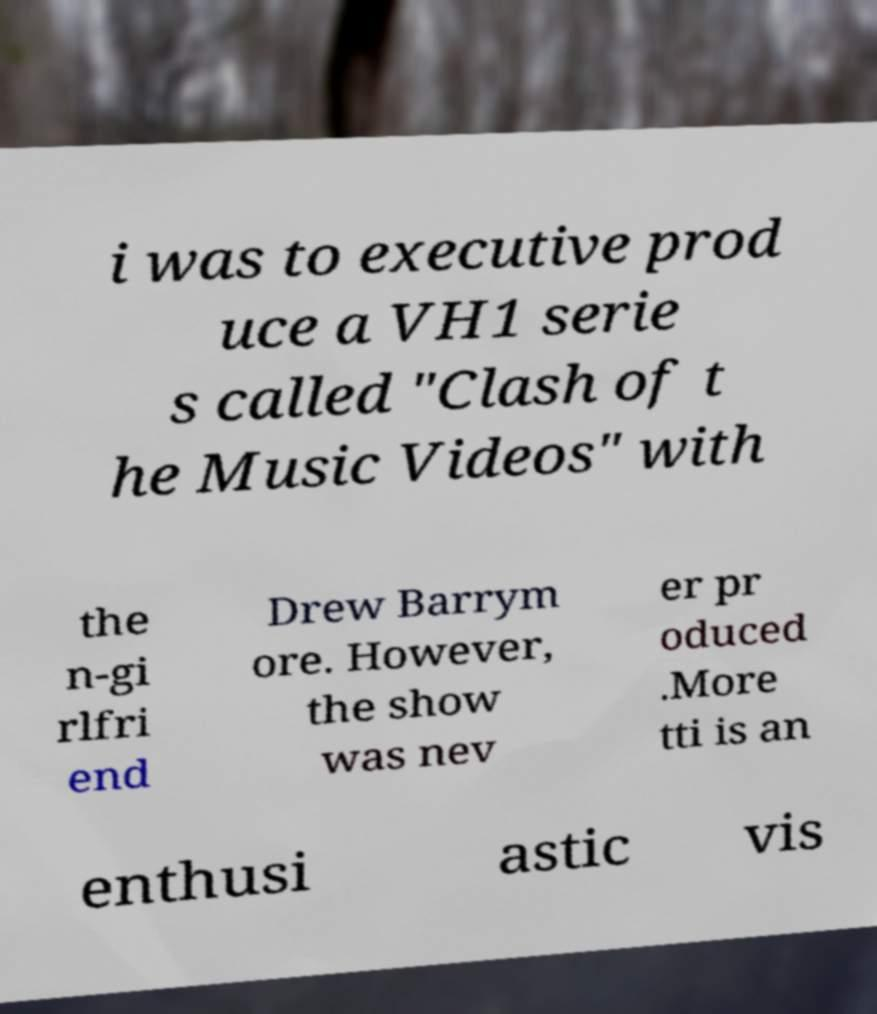Could you extract and type out the text from this image? i was to executive prod uce a VH1 serie s called "Clash of t he Music Videos" with the n-gi rlfri end Drew Barrym ore. However, the show was nev er pr oduced .More tti is an enthusi astic vis 